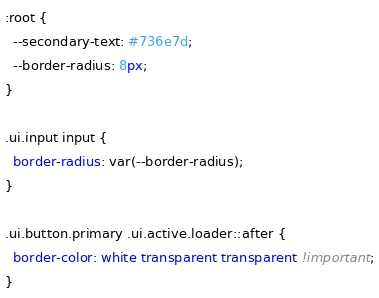Convert code to text. <code><loc_0><loc_0><loc_500><loc_500><_CSS_>:root {
  --secondary-text: #736e7d;
  --border-radius: 8px;
}

.ui.input input {
  border-radius: var(--border-radius);
}

.ui.button.primary .ui.active.loader::after {
  border-color: white transparent transparent !important;
}
</code> 